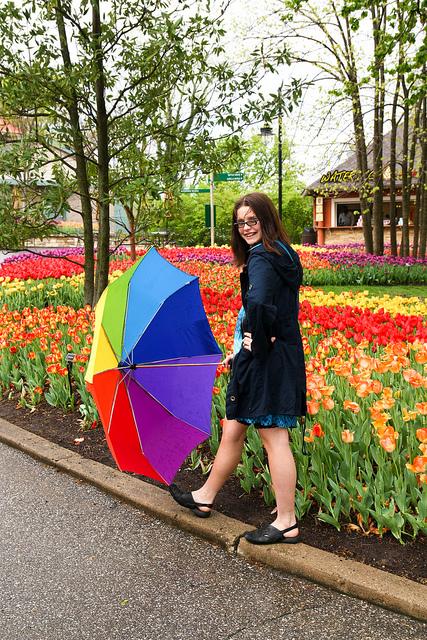How many colors are on the umbrella?
Be succinct. 8. What kind of flowers are in the background?
Give a very brief answer. Tulips. What style of shoes is she wearing?
Give a very brief answer. Crocs. 